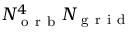<formula> <loc_0><loc_0><loc_500><loc_500>N _ { o r b } ^ { 4 } N _ { g r i d }</formula> 